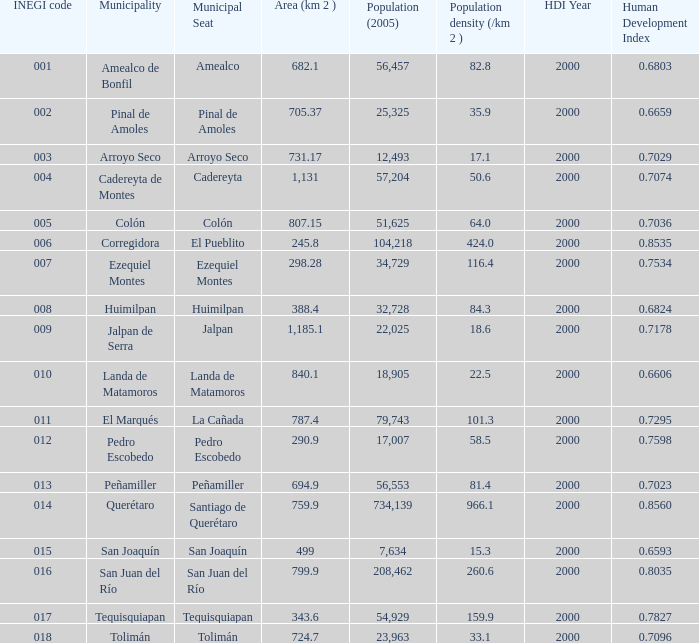Which Area (km 2 )has a Population (2005) of 57,204, and a Human Development Index (2000) smaller than 0.7074? 0.0. 